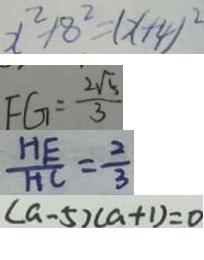<formula> <loc_0><loc_0><loc_500><loc_500>x ^ { 2 } + 8 ^ { 2 } = ( x + 4 ) ^ { 2 } 
 F G = \frac { 2 \sqrt { 5 } } { 3 } 
 \frac { H E } { H C } = \frac { 2 } { 3 } 
 ( a - 5 ) ( a + 1 ) = 0</formula> 